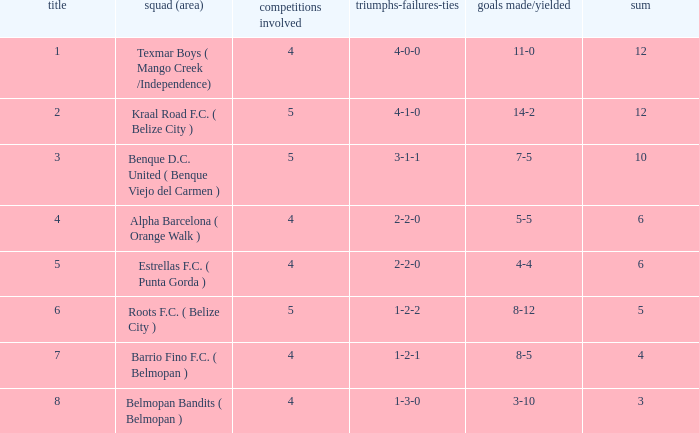What's the w-l-d with position being 1 4-0-0. 